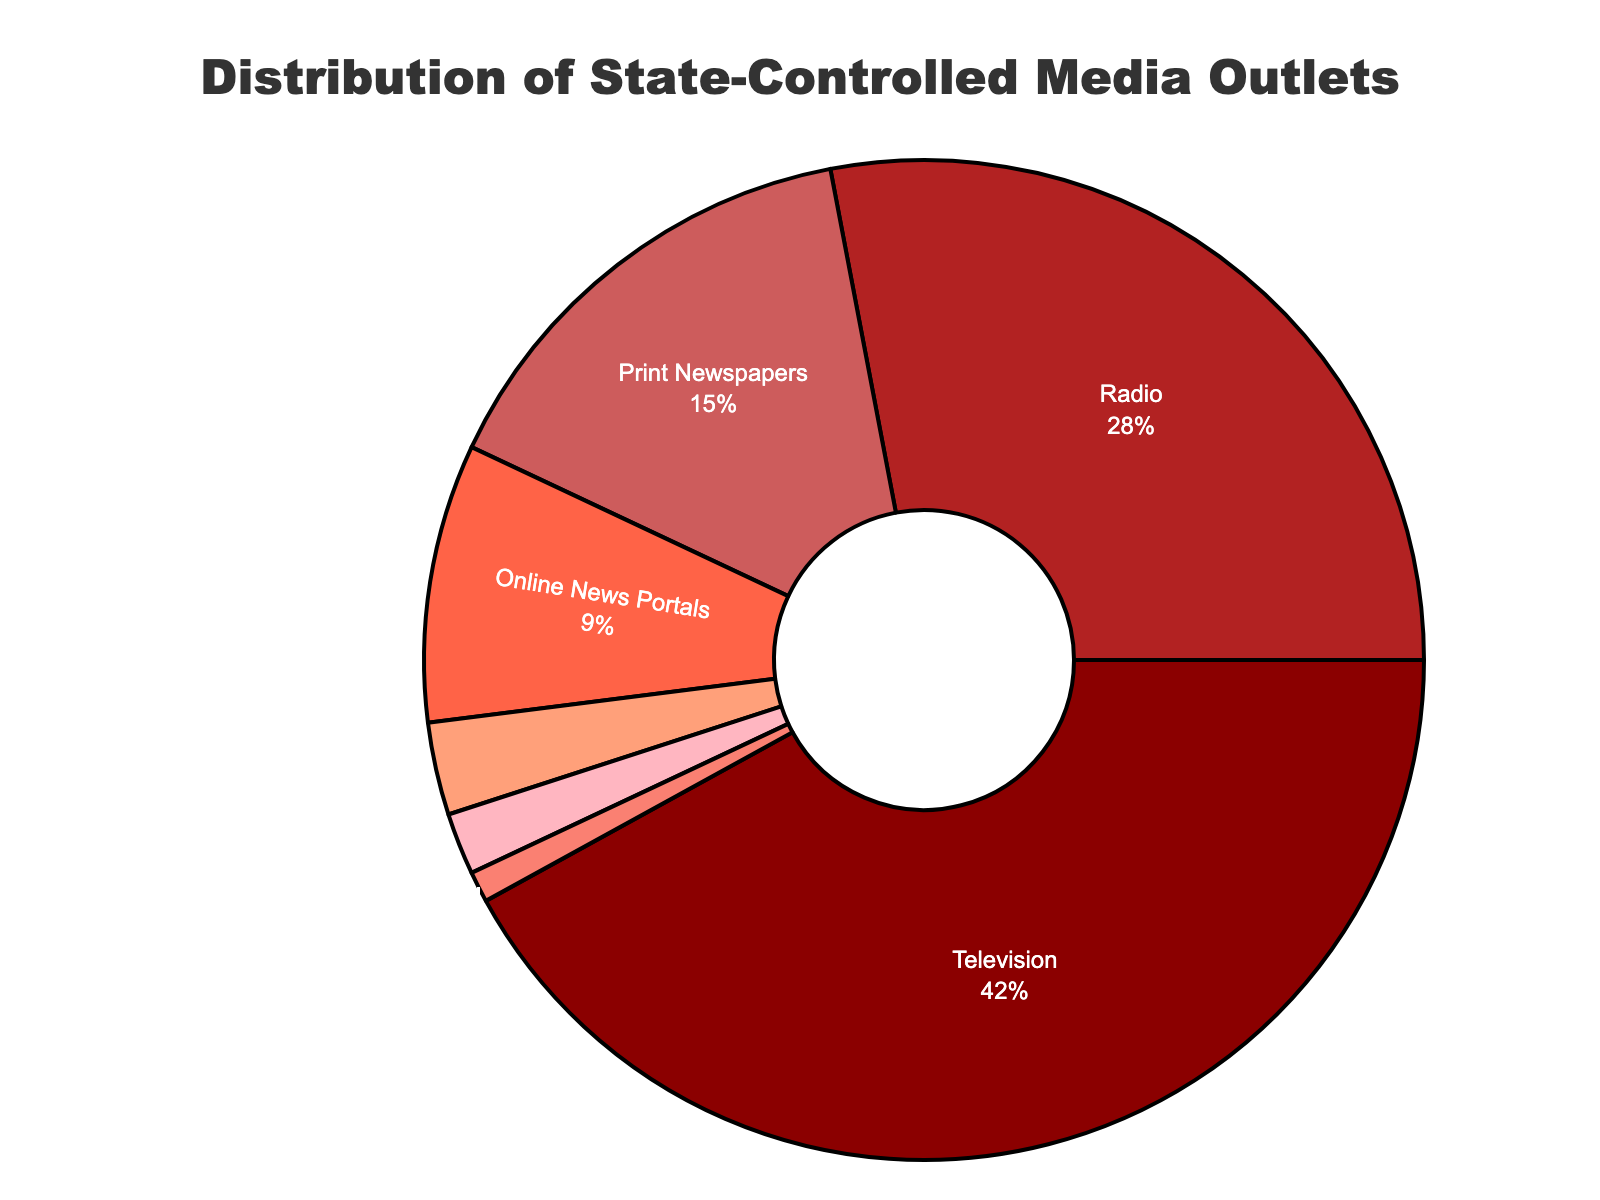what is the title of the figure? The title is written at the top of the figure: "Distribution of State-Controlled Media Outlets".
Answer: Distribution of State-Controlled Media Outlets what types of state-controlled media outlets are part of the distribution? The types of media outlets are listed as the labels in the pie chart: Television, Radio, Print Newspapers, Online News Portals, State News Agency, Social Media Platforms and Mobile Apps.
Answer: Television, Radio, Print Newspapers, Online News Portals, State News Agency, Social Media Platforms, Mobile Apps which type of media outlet has the largest share and what is its percentage? The largest share is represented by the sector with the largest slice and corresponding label in the pie chart. "Television" has the largest slice, and the label indicates that Television accounts for 42%.
Answer: Television, 42% how many more state-controlled radio outlets are there compared to state news agencies? We find the count for Radio and State News Agency in the figure data. Radio has 28 outlets, and State News Agency has 1 outlet. The difference is calculated as 28 - 1.
Answer: 27 what is the combined percentage share of print newspapers and online news portals? We add the percentages of Print Newspapers and Online News Portals from the pie chart labels. Print Newspapers have 15%, and Online News Portals have 9%. The combined percentage is 15% + 9%.
Answer: 24% which type of media outlet has the least number of entities and what is its count? From the pie chart, we identify the smallest slice with the corresponding label. "State News Agency" has the smallest slice, indicating 1 outlet.
Answer: State News Agency, 1 how does the share of social media platforms compare to mobile apps in terms of percentage? We look at the labels for Social Media Platforms and Mobile Apps. Social Media Platforms have 3% and Mobile Apps have 2%. Social Media Platforms have a higher share.
Answer: Social Media Platforms greater than Mobile Apps what is the total number of state-controlled media outlets displayed in the pie chart? We add up the counts of all media types presented in the pie chart. The counts are 42, 28, 15, 9, 1, 3, and 2. The total is 42 + 28 + 15 + 9 + 1 + 3 + 2.
Answer: 100 what percentage of the total is accounted for by mobile apps and social media platforms combined? We find the percentages in the pie chart for Mobile Apps (2%) and Social Media Platforms (3%). Adding these gives the combined percentage: 2% + 3%.
Answer: 5% how does the type with the second largest number of outlets compare to the type with the second smallest number of outlets? The second largest is Radio with 28 outlets, and the second smallest is Social Media Platforms with 3 outlets. Subtract the smaller number from the larger: 28 - 3.
Answer: 25 